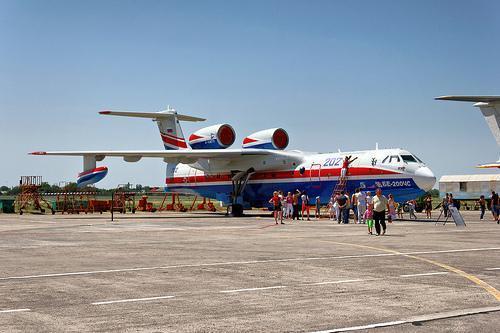How many planes are fully visible?
Give a very brief answer. 1. How many kids are wearing green pants?
Give a very brief answer. 1. 